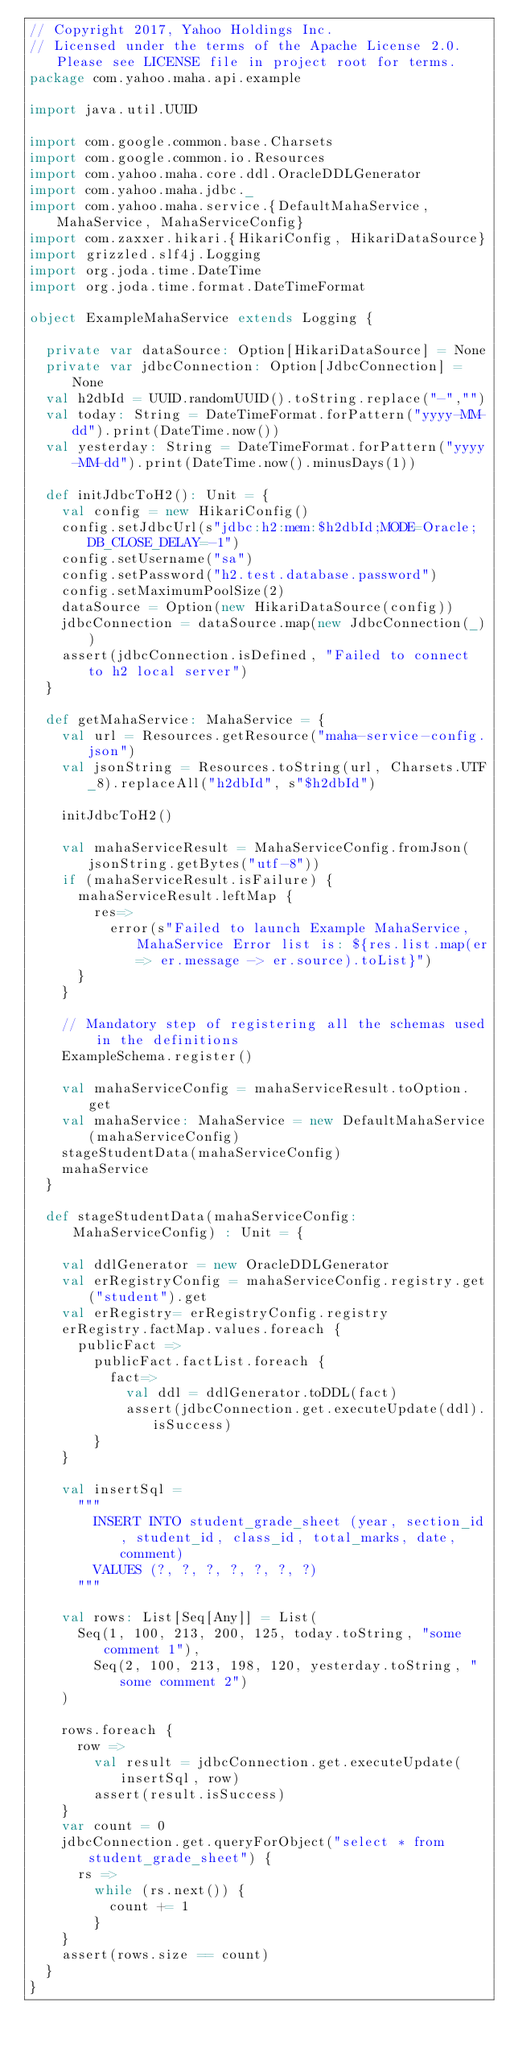<code> <loc_0><loc_0><loc_500><loc_500><_Scala_>// Copyright 2017, Yahoo Holdings Inc.
// Licensed under the terms of the Apache License 2.0. Please see LICENSE file in project root for terms.
package com.yahoo.maha.api.example

import java.util.UUID

import com.google.common.base.Charsets
import com.google.common.io.Resources
import com.yahoo.maha.core.ddl.OracleDDLGenerator
import com.yahoo.maha.jdbc._
import com.yahoo.maha.service.{DefaultMahaService, MahaService, MahaServiceConfig}
import com.zaxxer.hikari.{HikariConfig, HikariDataSource}
import grizzled.slf4j.Logging
import org.joda.time.DateTime
import org.joda.time.format.DateTimeFormat

object ExampleMahaService extends Logging {

  private var dataSource: Option[HikariDataSource] = None
  private var jdbcConnection: Option[JdbcConnection] = None
  val h2dbId = UUID.randomUUID().toString.replace("-","")
  val today: String = DateTimeFormat.forPattern("yyyy-MM-dd").print(DateTime.now())
  val yesterday: String = DateTimeFormat.forPattern("yyyy-MM-dd").print(DateTime.now().minusDays(1))

  def initJdbcToH2(): Unit = {
    val config = new HikariConfig()
    config.setJdbcUrl(s"jdbc:h2:mem:$h2dbId;MODE=Oracle;DB_CLOSE_DELAY=-1")
    config.setUsername("sa")
    config.setPassword("h2.test.database.password")
    config.setMaximumPoolSize(2)
    dataSource = Option(new HikariDataSource(config))
    jdbcConnection = dataSource.map(new JdbcConnection(_))
    assert(jdbcConnection.isDefined, "Failed to connect to h2 local server")
  }

  def getMahaService: MahaService = {
    val url = Resources.getResource("maha-service-config.json")
    val jsonString = Resources.toString(url, Charsets.UTF_8).replaceAll("h2dbId", s"$h2dbId")

    initJdbcToH2()

    val mahaServiceResult = MahaServiceConfig.fromJson(jsonString.getBytes("utf-8"))
    if (mahaServiceResult.isFailure) {
      mahaServiceResult.leftMap {
        res=>
          error(s"Failed to launch Example MahaService, MahaService Error list is: ${res.list.map(er=> er.message -> er.source).toList}")
      }
    }

    // Mandatory step of registering all the schemas used in the definitions
    ExampleSchema.register()

    val mahaServiceConfig = mahaServiceResult.toOption.get
    val mahaService: MahaService = new DefaultMahaService(mahaServiceConfig)
    stageStudentData(mahaServiceConfig)
    mahaService
  }

  def stageStudentData(mahaServiceConfig: MahaServiceConfig) : Unit = {

    val ddlGenerator = new OracleDDLGenerator
    val erRegistryConfig = mahaServiceConfig.registry.get("student").get
    val erRegistry= erRegistryConfig.registry
    erRegistry.factMap.values.foreach {
      publicFact =>
        publicFact.factList.foreach {
          fact=>
            val ddl = ddlGenerator.toDDL(fact)
            assert(jdbcConnection.get.executeUpdate(ddl).isSuccess)
        }
    }

    val insertSql =
      """
        INSERT INTO student_grade_sheet (year, section_id, student_id, class_id, total_marks, date, comment)
        VALUES (?, ?, ?, ?, ?, ?, ?)
      """

    val rows: List[Seq[Any]] = List(
      Seq(1, 100, 213, 200, 125, today.toString, "some comment 1"),
        Seq(2, 100, 213, 198, 120, yesterday.toString, "some comment 2")
    )

    rows.foreach {
      row =>
        val result = jdbcConnection.get.executeUpdate(insertSql, row)
        assert(result.isSuccess)
    }
    var count = 0
    jdbcConnection.get.queryForObject("select * from student_grade_sheet") {
      rs =>
        while (rs.next()) {
          count += 1
        }
    }
    assert(rows.size == count)
  }
}
</code> 